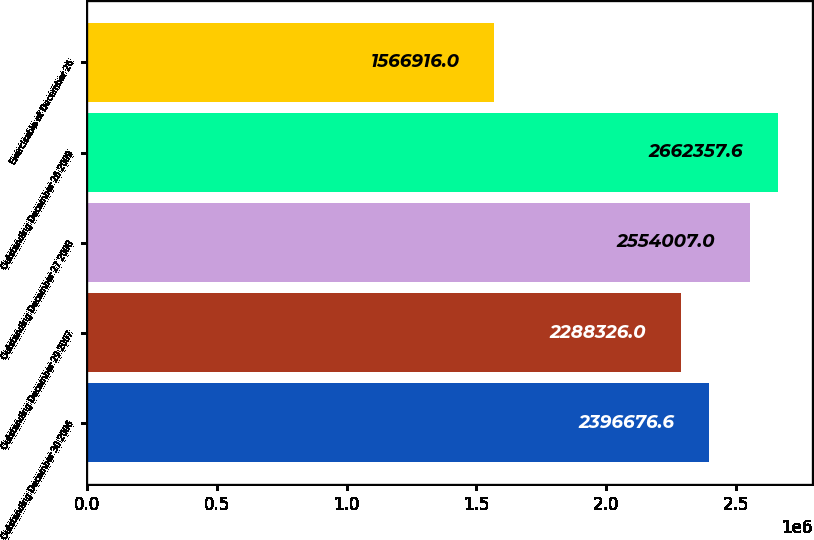Convert chart to OTSL. <chart><loc_0><loc_0><loc_500><loc_500><bar_chart><fcel>Outstanding December 30 2006<fcel>Outstanding December 29 2007<fcel>Outstanding December 27 2008<fcel>Outstanding December 26 2009<fcel>Exercisable at December 26<nl><fcel>2.39668e+06<fcel>2.28833e+06<fcel>2.55401e+06<fcel>2.66236e+06<fcel>1.56692e+06<nl></chart> 